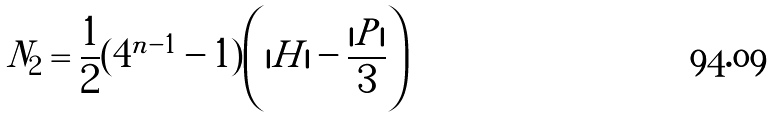Convert formula to latex. <formula><loc_0><loc_0><loc_500><loc_500>N _ { 2 } = \frac { 1 } { 2 } ( 4 ^ { n - 1 } - 1 ) \left ( | H | - \frac { | P | } { 3 } \right )</formula> 